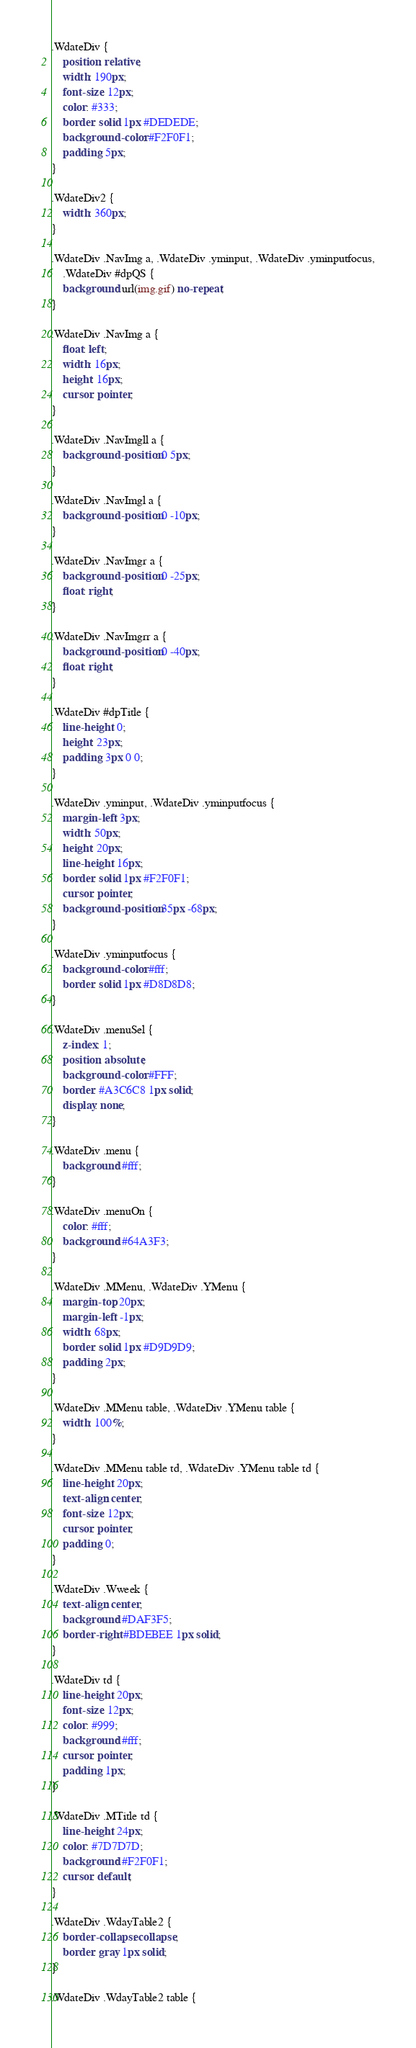<code> <loc_0><loc_0><loc_500><loc_500><_CSS_>.WdateDiv {
	position: relative;
	width: 190px;
	font-size: 12px;
	color: #333;
	border: solid 1px #DEDEDE;
	background-color: #F2F0F1;
	padding: 5px;
}

.WdateDiv2 {
	width: 360px;
}

.WdateDiv .NavImg a, .WdateDiv .yminput, .WdateDiv .yminputfocus,
	.WdateDiv #dpQS {
	background: url(img.gif) no-repeat;
}

.WdateDiv .NavImg a {
	float: left;
	width: 16px;
	height: 16px;
	cursor: pointer;
}

.WdateDiv .NavImgll a {
	background-position: 0 5px;
}

.WdateDiv .NavImgl a {
	background-position: 0 -10px;
}

.WdateDiv .NavImgr a {
	background-position: 0 -25px;
	float: right;
}

.WdateDiv .NavImgrr a {
	background-position: 0 -40px;
	float: right;
}

.WdateDiv #dpTitle {
	line-height: 0;
	height: 23px;
	padding: 3px 0 0;
}

.WdateDiv .yminput, .WdateDiv .yminputfocus {
	margin-left: 3px;
	width: 50px;
	height: 20px;
	line-height: 16px;
	border: solid 1px #F2F0F1;
	cursor: pointer;
	background-position: 35px -68px;
}

.WdateDiv .yminputfocus {
	background-color: #fff;
	border: solid 1px #D8D8D8;
}

.WdateDiv .menuSel {
	z-index: 1;
	position: absolute;
	background-color: #FFF;
	border: #A3C6C8 1px solid;
	display: none;
}

.WdateDiv .menu {
	background: #fff;
}

.WdateDiv .menuOn {
	color: #fff;
	background: #64A3F3;
}

.WdateDiv .MMenu, .WdateDiv .YMenu {
	margin-top: 20px;
	margin-left: -1px;
	width: 68px;
	border: solid 1px #D9D9D9;
	padding: 2px;
}

.WdateDiv .MMenu table, .WdateDiv .YMenu table {
	width: 100%;
}

.WdateDiv .MMenu table td, .WdateDiv .YMenu table td {
	line-height: 20px;
	text-align: center;
	font-size: 12px;
	cursor: pointer;
	padding: 0;
}

.WdateDiv .Wweek {
	text-align: center;
	background: #DAF3F5;
	border-right: #BDEBEE 1px solid;
}

.WdateDiv td {
	line-height: 20px;
	font-size: 12px;
	color: #999;
	background: #fff;
	cursor: pointer;
	padding: 1px;
}

.WdateDiv .MTitle td {
	line-height: 24px;
	color: #7D7D7D;
	background: #F2F0F1;
	cursor: default;
}

.WdateDiv .WdayTable2 {
	border-collapse: collapse;
	border: gray 1px solid;
}

.WdateDiv .WdayTable2 table {</code> 